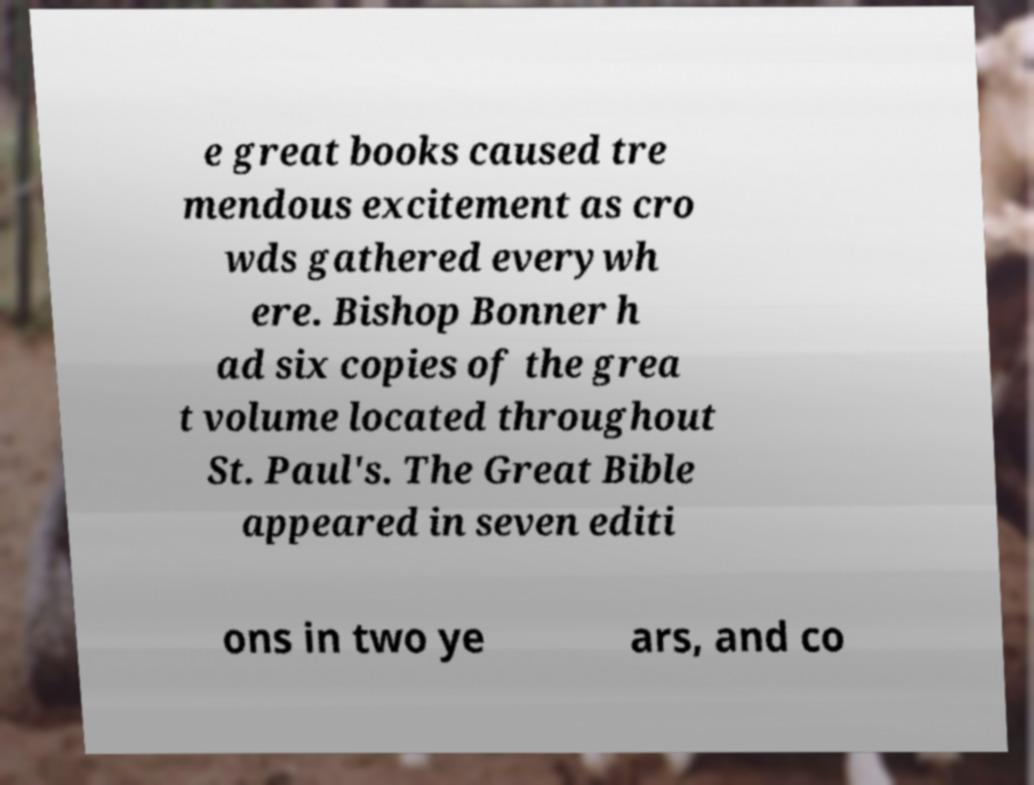What messages or text are displayed in this image? I need them in a readable, typed format. e great books caused tre mendous excitement as cro wds gathered everywh ere. Bishop Bonner h ad six copies of the grea t volume located throughout St. Paul's. The Great Bible appeared in seven editi ons in two ye ars, and co 